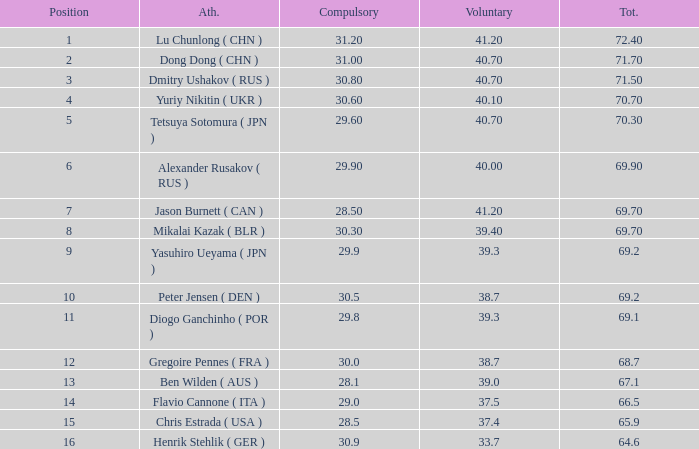What's the position that has a total less than 66.5m, a compulsory of 30.9 and voluntary less than 33.7? None. Would you mind parsing the complete table? {'header': ['Position', 'Ath.', 'Compulsory', 'Voluntary', 'Tot.'], 'rows': [['1', 'Lu Chunlong ( CHN )', '31.20', '41.20', '72.40'], ['2', 'Dong Dong ( CHN )', '31.00', '40.70', '71.70'], ['3', 'Dmitry Ushakov ( RUS )', '30.80', '40.70', '71.50'], ['4', 'Yuriy Nikitin ( UKR )', '30.60', '40.10', '70.70'], ['5', 'Tetsuya Sotomura ( JPN )', '29.60', '40.70', '70.30'], ['6', 'Alexander Rusakov ( RUS )', '29.90', '40.00', '69.90'], ['7', 'Jason Burnett ( CAN )', '28.50', '41.20', '69.70'], ['8', 'Mikalai Kazak ( BLR )', '30.30', '39.40', '69.70'], ['9', 'Yasuhiro Ueyama ( JPN )', '29.9', '39.3', '69.2'], ['10', 'Peter Jensen ( DEN )', '30.5', '38.7', '69.2'], ['11', 'Diogo Ganchinho ( POR )', '29.8', '39.3', '69.1'], ['12', 'Gregoire Pennes ( FRA )', '30.0', '38.7', '68.7'], ['13', 'Ben Wilden ( AUS )', '28.1', '39.0', '67.1'], ['14', 'Flavio Cannone ( ITA )', '29.0', '37.5', '66.5'], ['15', 'Chris Estrada ( USA )', '28.5', '37.4', '65.9'], ['16', 'Henrik Stehlik ( GER )', '30.9', '33.7', '64.6']]} 